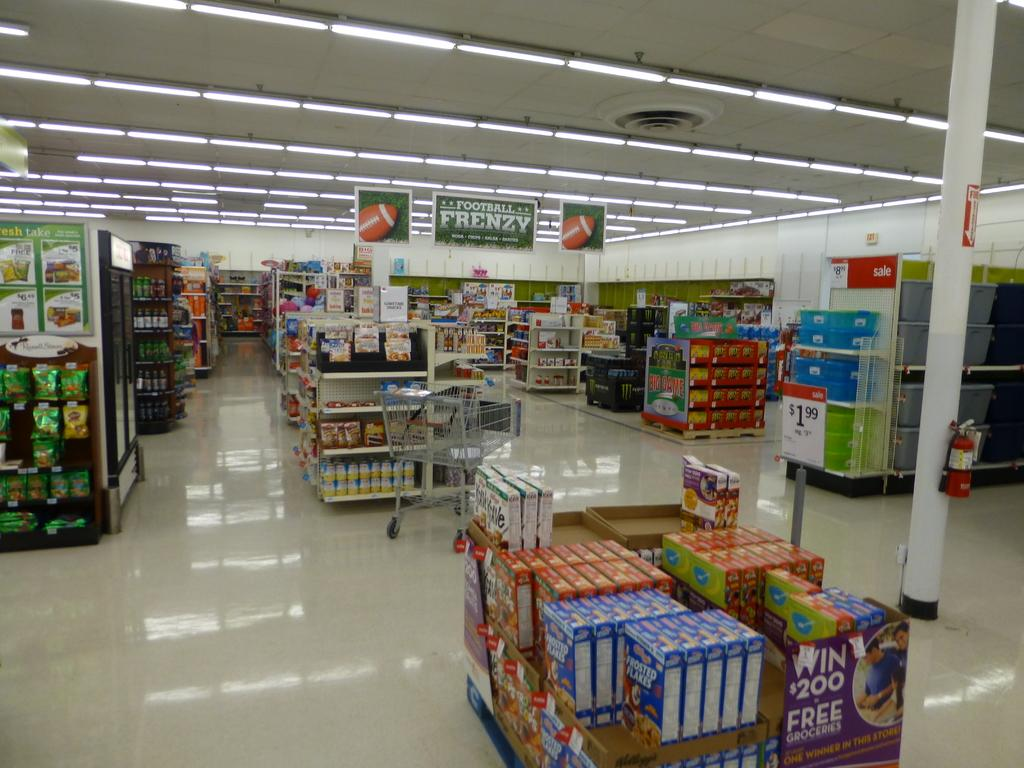<image>
Describe the image concisely. Empty store aisle with a large sign saying Football Frenzy. 